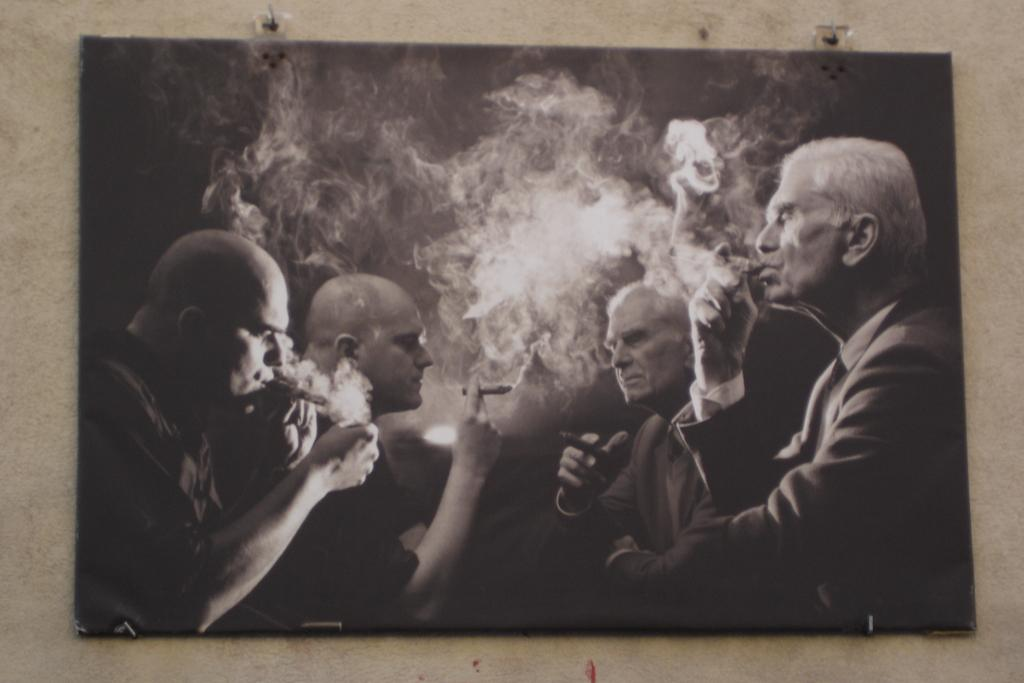What is hanging on the wall in the image? There is a wall hanging in the image. What color scheme is used for the wall hanging? The wall hanging is in black and white. What is depicted on the wall hanging? The wall hanging depicts men smoking. How many pigs are visible in the image? There are no pigs present in the image; it features a wall hanging depicting men smoking. What type of company is shown in the image? There is no company depicted in the image; it features a wall hanging with men smoking. 